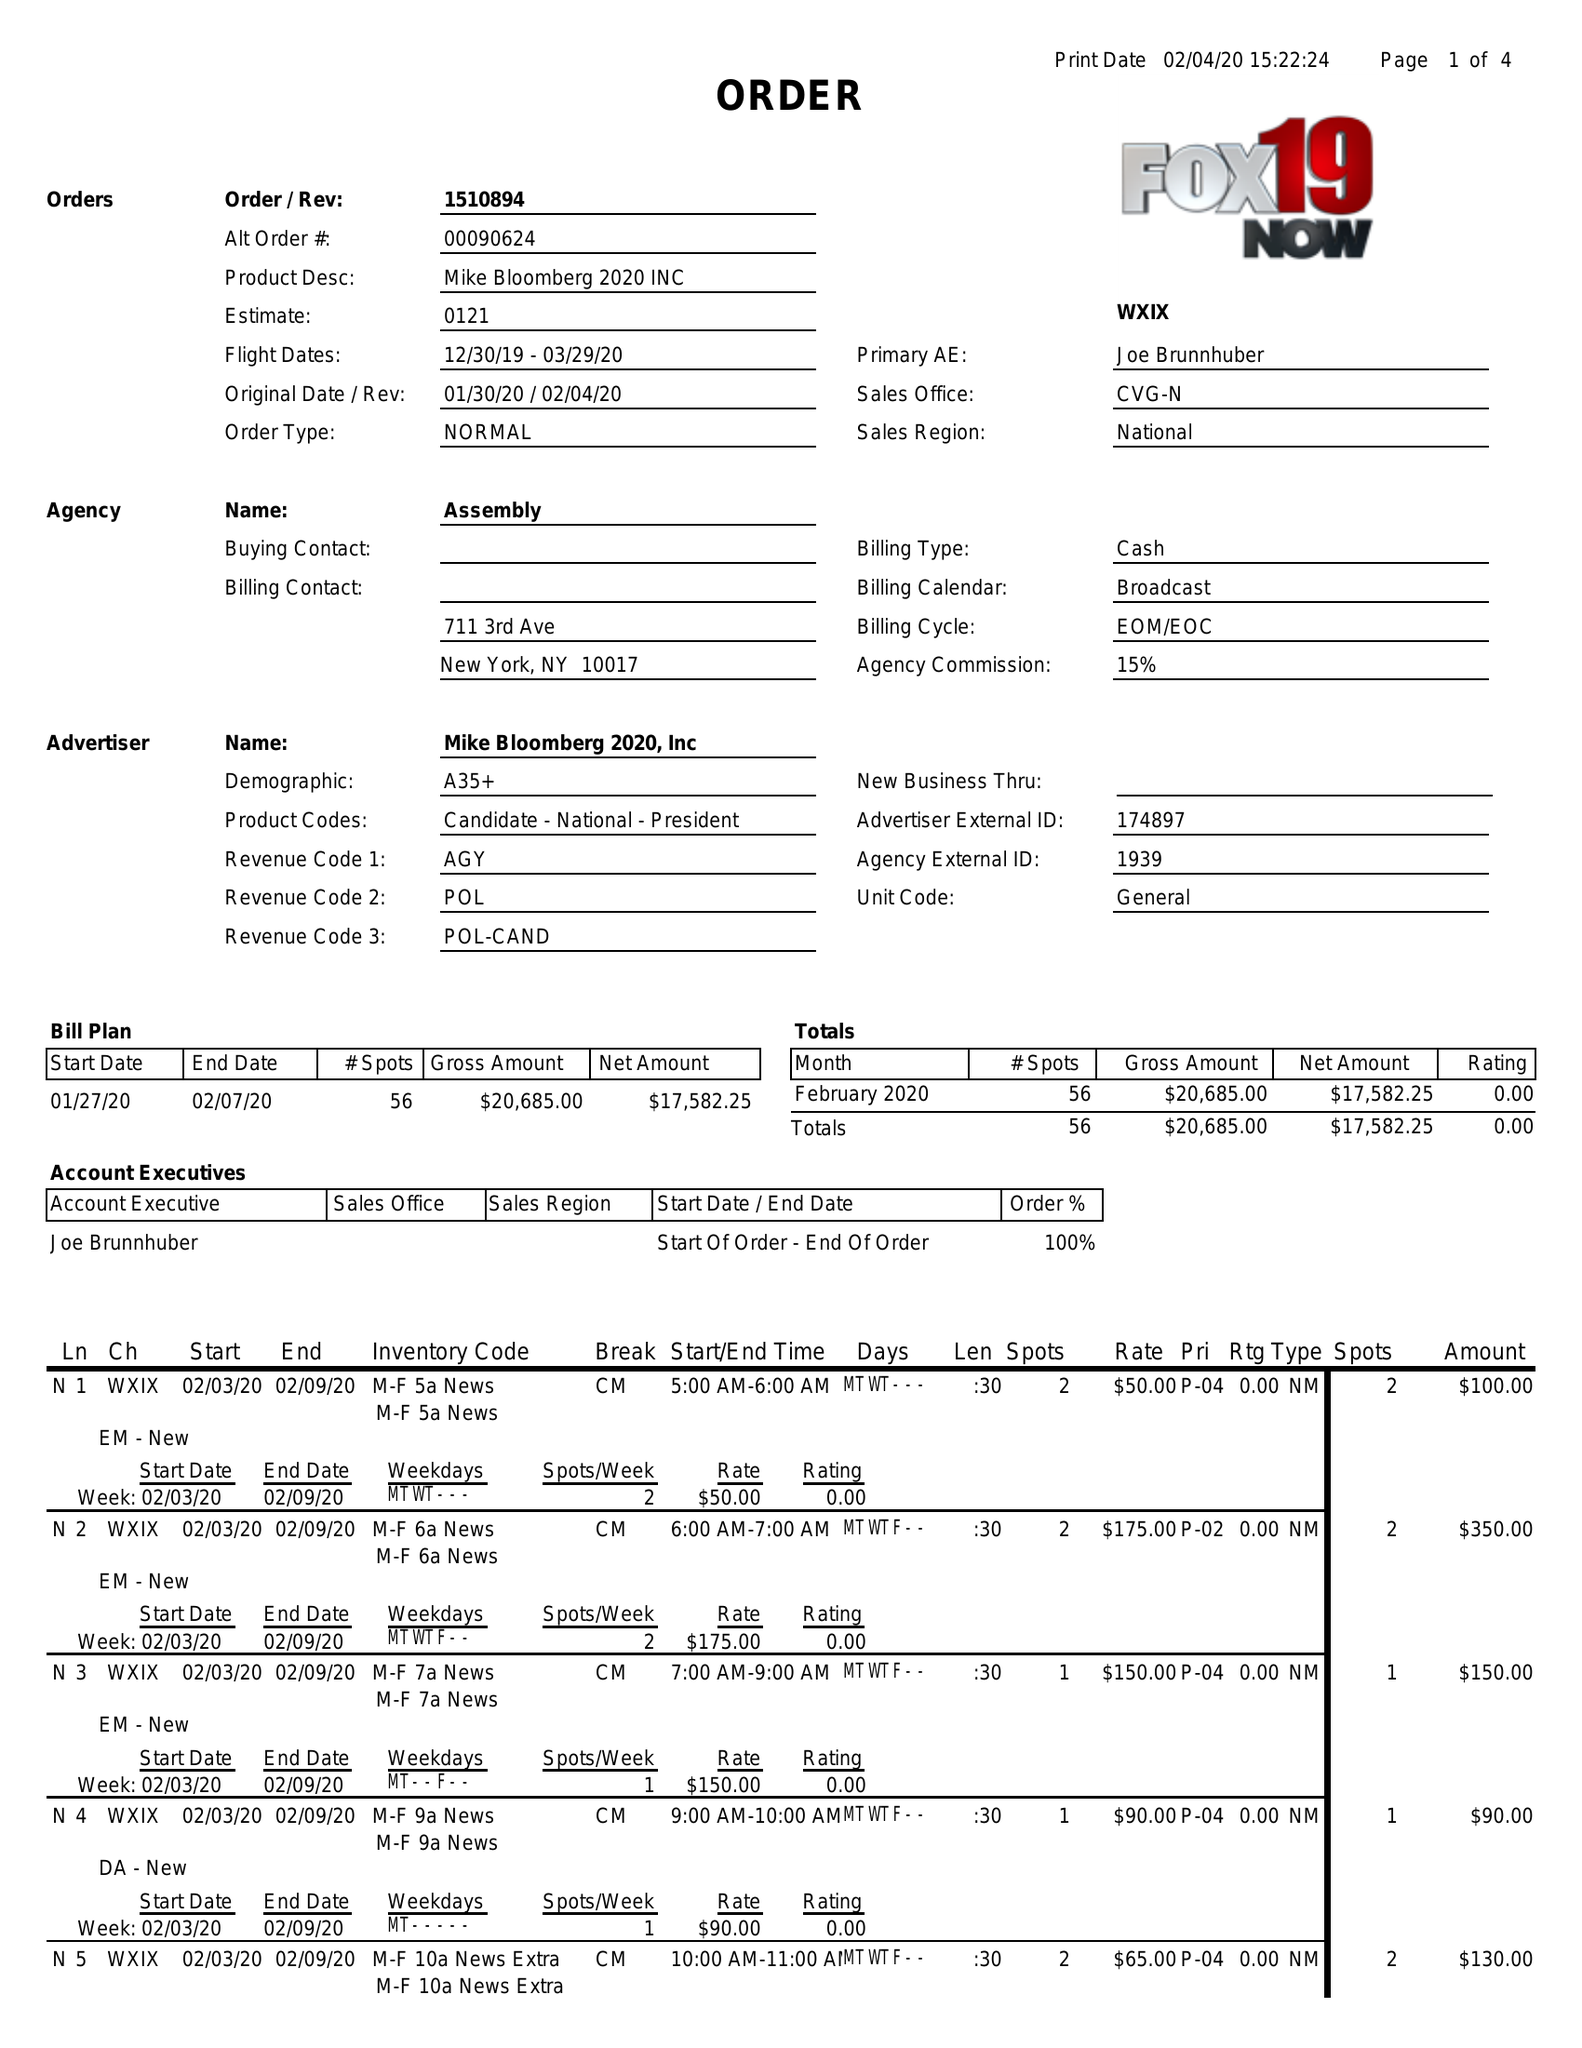What is the value for the flight_to?
Answer the question using a single word or phrase. 03/29/20 